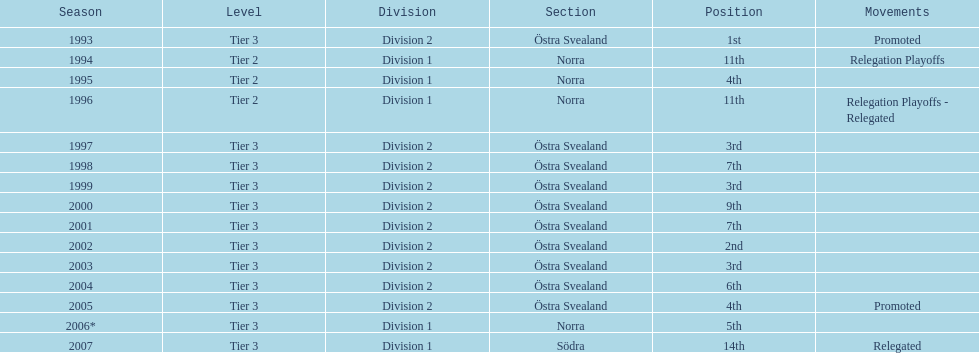In what season did visby if gute fk finish first in division 2 tier 3? 1993. 